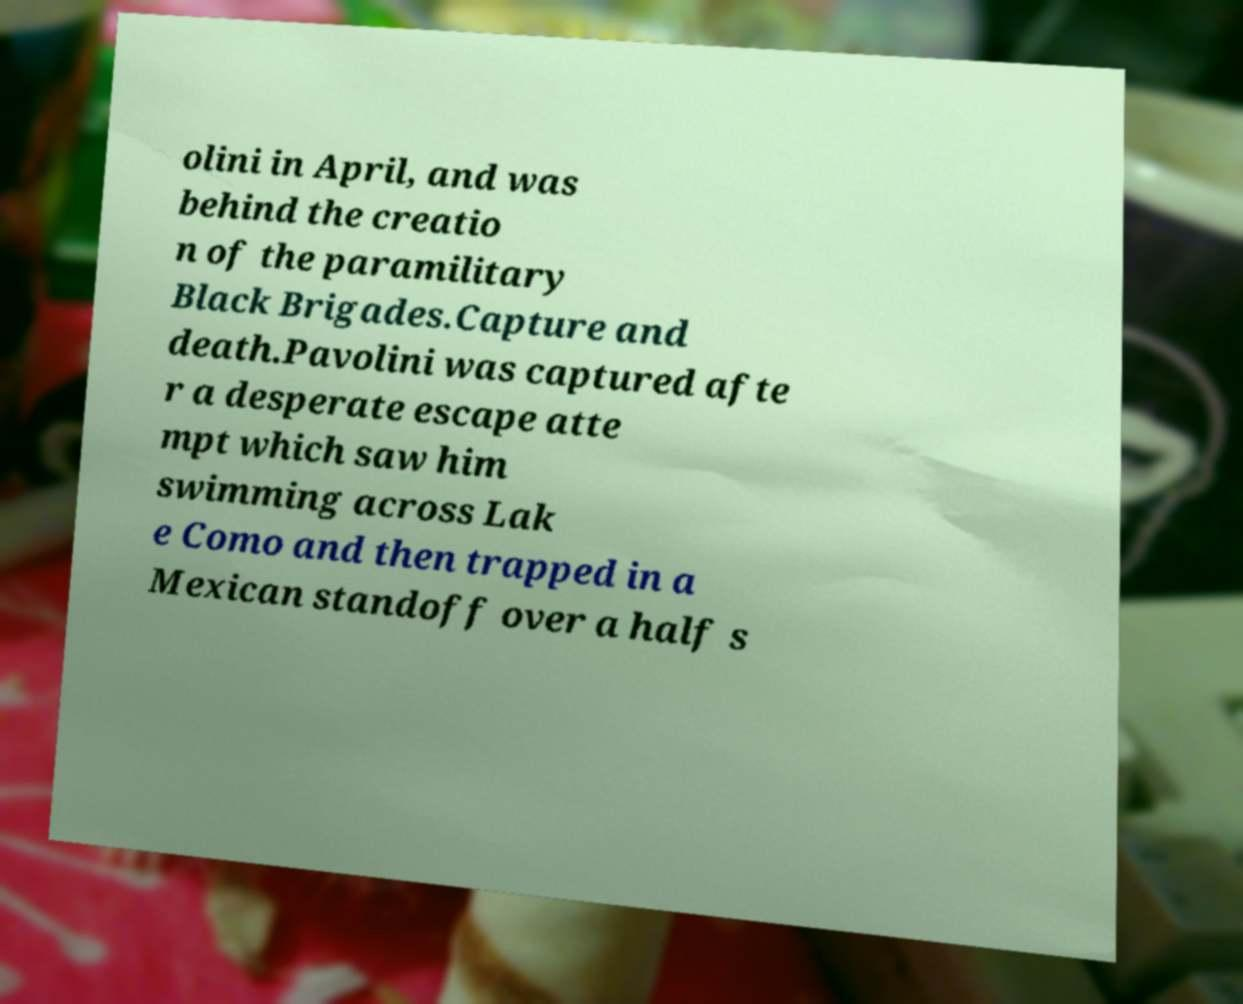Can you accurately transcribe the text from the provided image for me? olini in April, and was behind the creatio n of the paramilitary Black Brigades.Capture and death.Pavolini was captured afte r a desperate escape atte mpt which saw him swimming across Lak e Como and then trapped in a Mexican standoff over a half s 